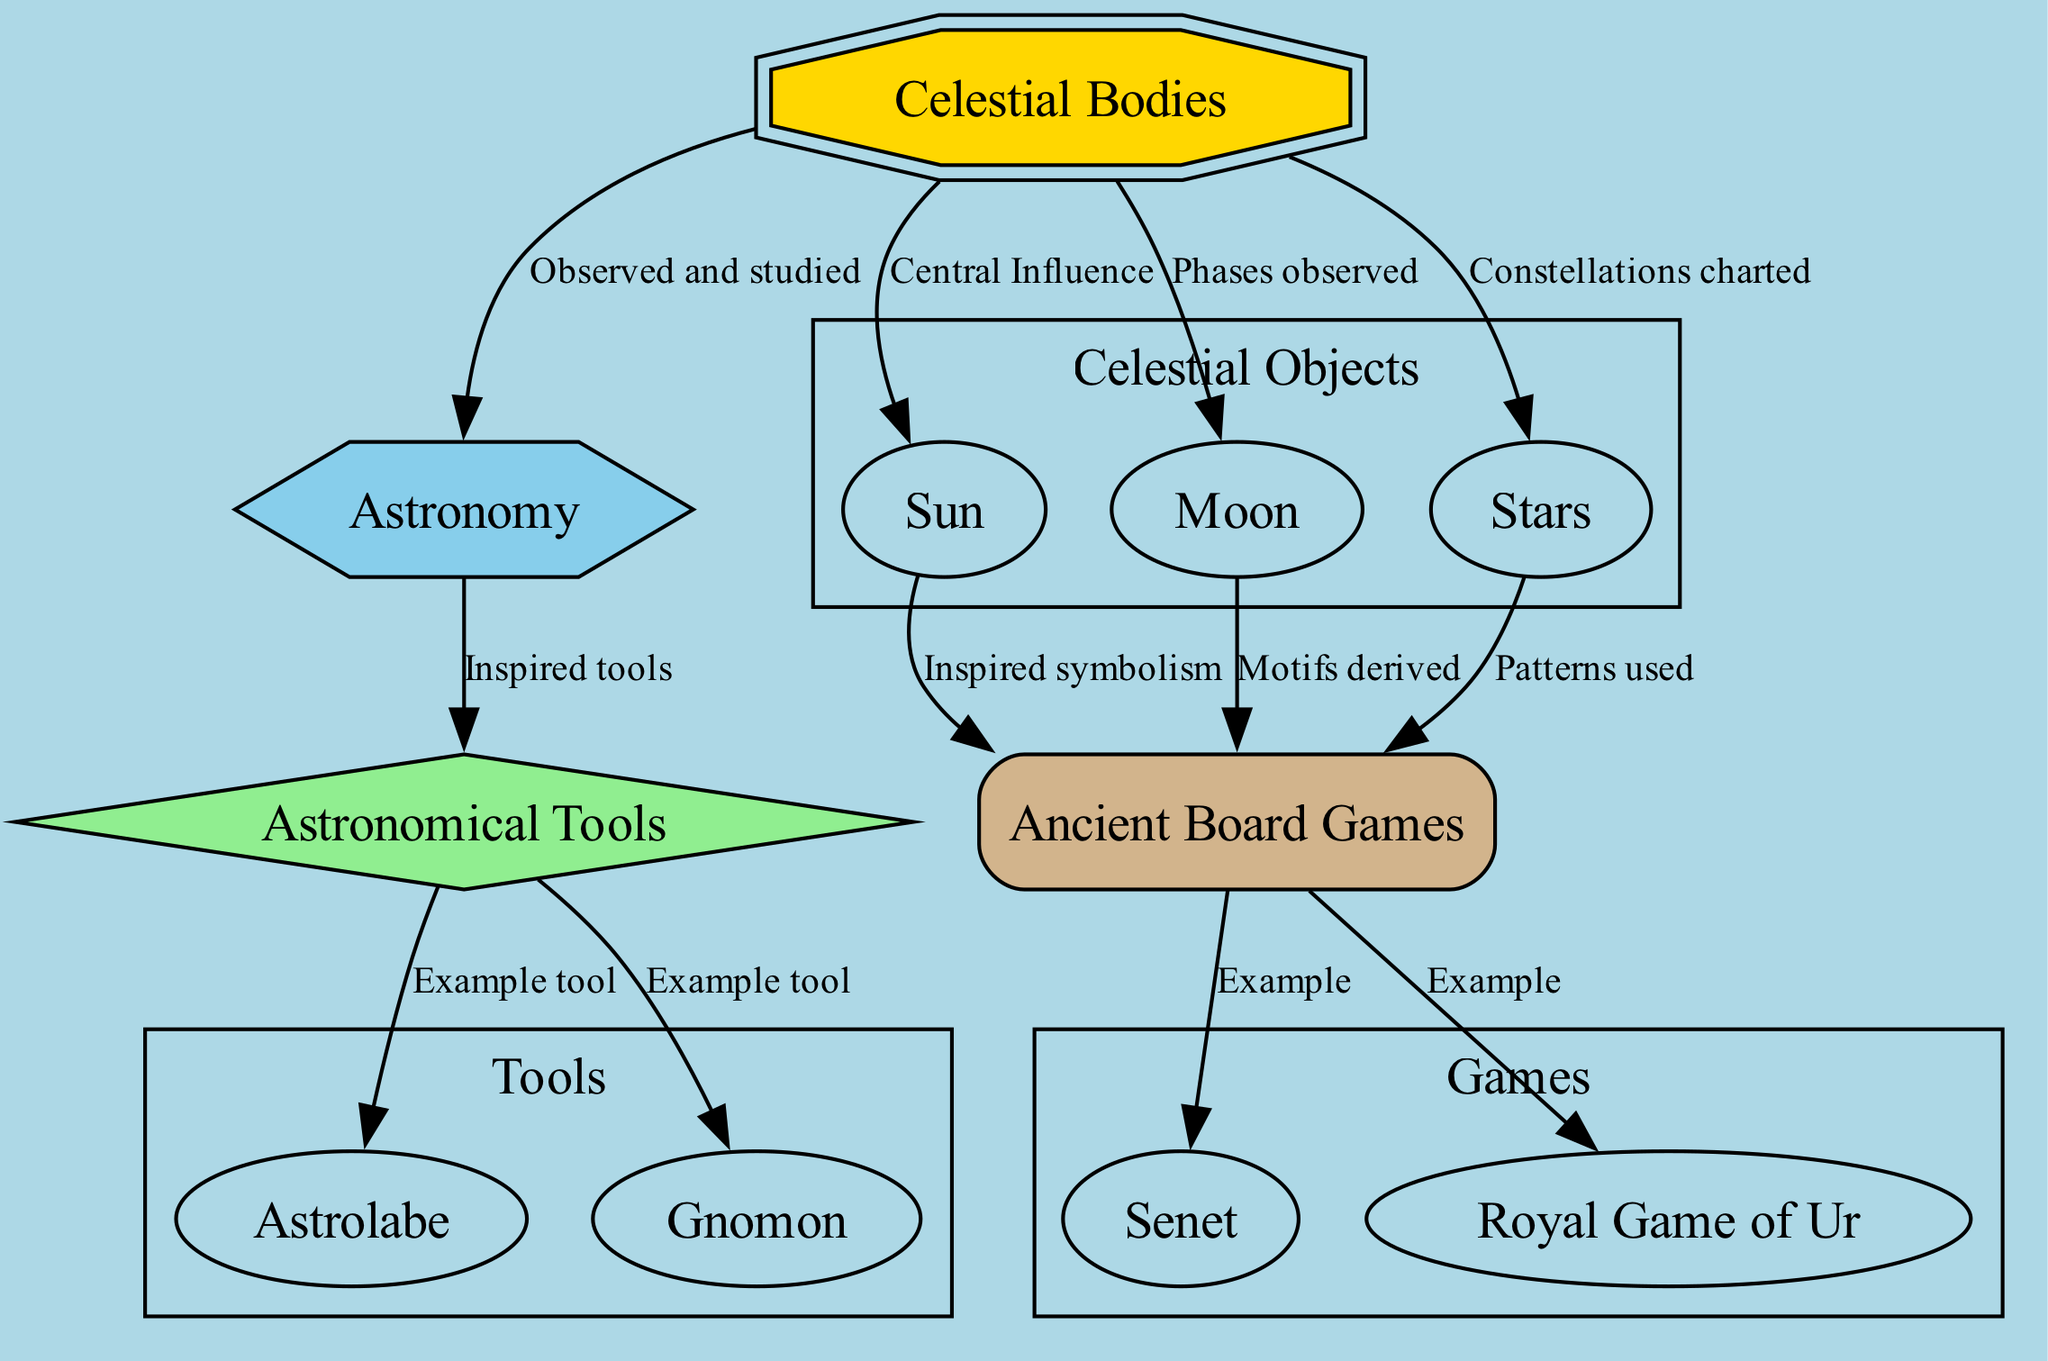What is the central influence in the diagram? The diagram specifies the "Sun" as the central star influencing various aspects such as timekeeping and calendars in ancient cultures. This is explicitly indicated by the edge connecting "Celestial Bodies" to "Sun" labeled as "Central Influence."
Answer: Sun How many nodes are there in the diagram? By counting the nodes listed: "Celestial Bodies," "Astronomy," "Sun," "Moon," "Stars," "Ancient Board Games," "Senet," "Royal Game of Ur," "Astronomical Tools," "Astrolabe," and "Gnomon," we find there are a total of 11 nodes.
Answer: 11 What game is linked to solar and lunar cycles? The node labeled "Senet" is specifically described in the diagram as an Egyptian board game linked to solar and lunar cycles, which clearly indicates its connection.
Answer: Senet Which tool is used to tell time using the sun? The diagram identifies the "Gnomon" as a device that uses the sun for timekeeping, marked clearly in its description. It is related to the edge connecting "Astronomical Tools" to "Gnomon."
Answer: Gnomon What do stars represent in ancient navigation? The "Stars" node highlights that constellations from stars were used for navigation and storytelling, as indicated in its description, explaining their importance in guiding explorers.
Answer: Constellations Which celestial body is associated with ancient calendrical systems? The "Moon" is explicitly stated in the diagram to have phases that were used in ancient calendrical systems, evidenced by the connecting label "Phases observed."
Answer: Moon How are ancient games influenced by celestial movements? The connections from "Celestial Bodies" to "Ancient Board Games" through "Sun," "Moon," and "Stars" illustrate the influence, leading to the development of games like "Senet" and "Royal Game of Ur" that are designed reflecting celestial themes.
Answer: Through sunlight, lunar phases, and constellations What is the relationship between "Astronomy" and "Astronomical Tools"? The edge from "Astronomy" to "Astronomical Tools" labeled "Inspired tools" signifies the relationship where the study of celestial bodies led to the creation of instruments for observation.
Answer: Inspired tools 